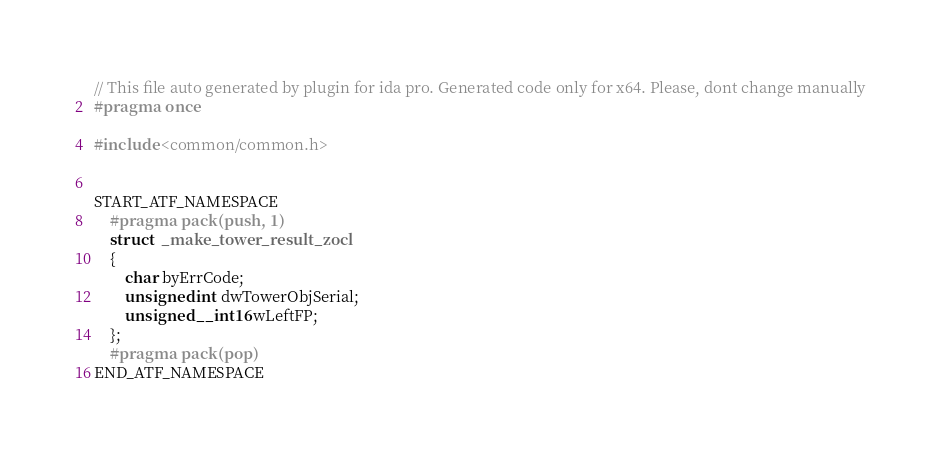<code> <loc_0><loc_0><loc_500><loc_500><_C++_>// This file auto generated by plugin for ida pro. Generated code only for x64. Please, dont change manually
#pragma once

#include <common/common.h>


START_ATF_NAMESPACE
    #pragma pack(push, 1)
    struct  _make_tower_result_zocl
    {
        char byErrCode;
        unsigned int dwTowerObjSerial;
        unsigned __int16 wLeftFP;
    };
    #pragma pack(pop)
END_ATF_NAMESPACE
</code> 